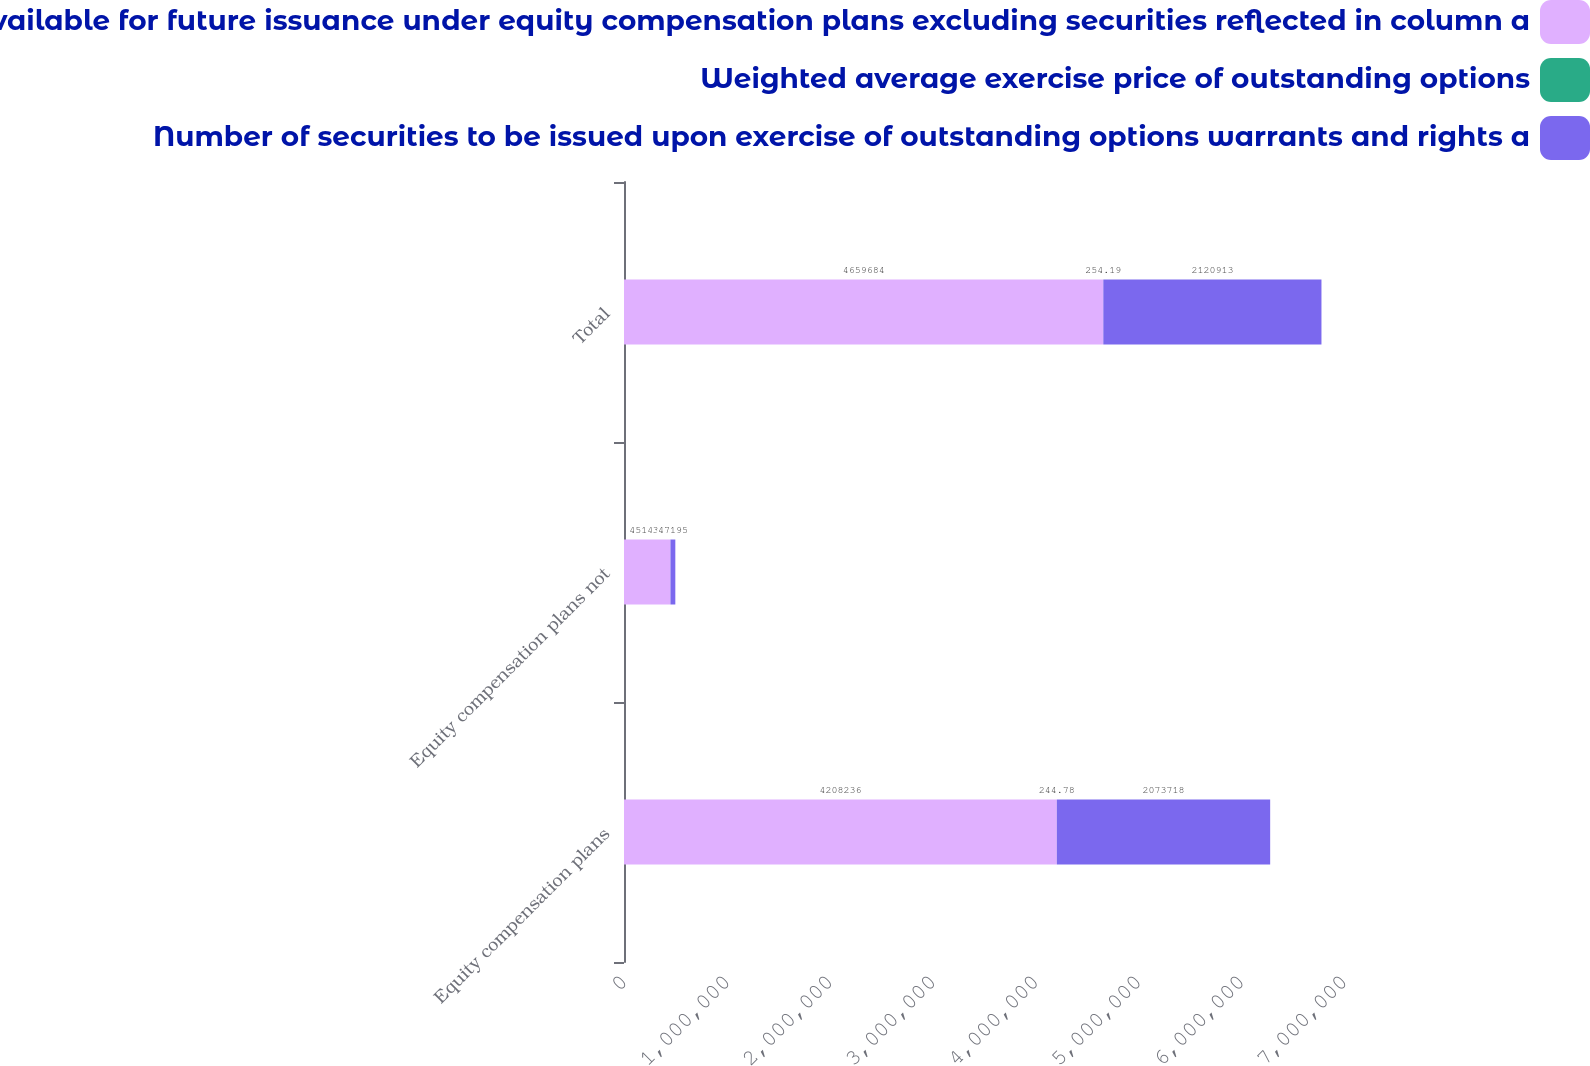Convert chart to OTSL. <chart><loc_0><loc_0><loc_500><loc_500><stacked_bar_chart><ecel><fcel>Equity compensation plans<fcel>Equity compensation plans not<fcel>Total<nl><fcel>Number of securities remaining available for future issuance under equity compensation plans excluding securities reflected in column a<fcel>4.20824e+06<fcel>451448<fcel>4.65968e+06<nl><fcel>Weighted average exercise price of outstanding options<fcel>244.78<fcel>341.86<fcel>254.19<nl><fcel>Number of securities to be issued upon exercise of outstanding options warrants and rights a<fcel>2.07372e+06<fcel>47195<fcel>2.12091e+06<nl></chart> 